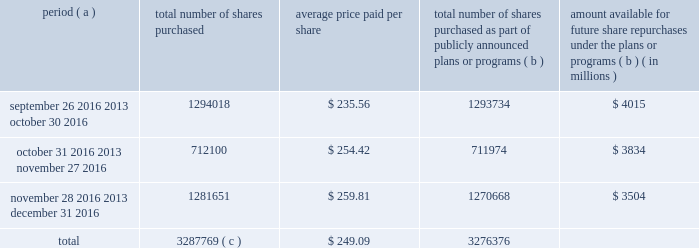Purchases of equity securities the table provides information about our repurchases of our common stock registered pursuant to section 12 of the exchange act during the quarter ended december 31 , 2016 .
Period ( a ) number of shares purchased average price paid per share total number of shares purchased as part of publicly announced plans or programs ( b ) amount available for future share repurchases under the plans or programs ( b ) ( in millions ) .
Total 3287769 ( c ) $ 249.09 3276376 ( a ) we close our books and records on the last sunday of each month to align our financial closing with our business processes , except for the month of december , as our fiscal year ends on december 31 .
As a result , our fiscal months often differ from the calendar months .
For example , september 26 , 2016 was the first day of our october 2016 fiscal month .
( b ) in october 2010 , our board of directors approved a share repurchase program pursuant to which we are authorized to repurchase our common stock in privately negotiated transactions or in the open market at prices per share not exceeding the then-current market prices .
On september 22 , 2016 , our board of directors authorized a $ 2.0 billion increase to the program .
Under the program , management has discretion to determine the dollar amount of shares to be repurchased and the timing of any repurchases in compliance with applicable law and regulation .
This includes purchases pursuant to rule 10b5-1 plans .
The program does not have an expiration date .
( c ) during the quarter ended december 31 , 2016 , the total number of shares purchased included 11393 shares that were transferred to us by employees in satisfaction of minimum tax withholding obligations associated with the vesting of restricted stock units .
These purchases were made pursuant to a separate authorization by our board of directors and are not included within the program. .
What was the average number of shares repurchased per month for the 3 months ending december 31 , 2016? 
Computations: (3287769 / 3)
Answer: 1095923.0. 